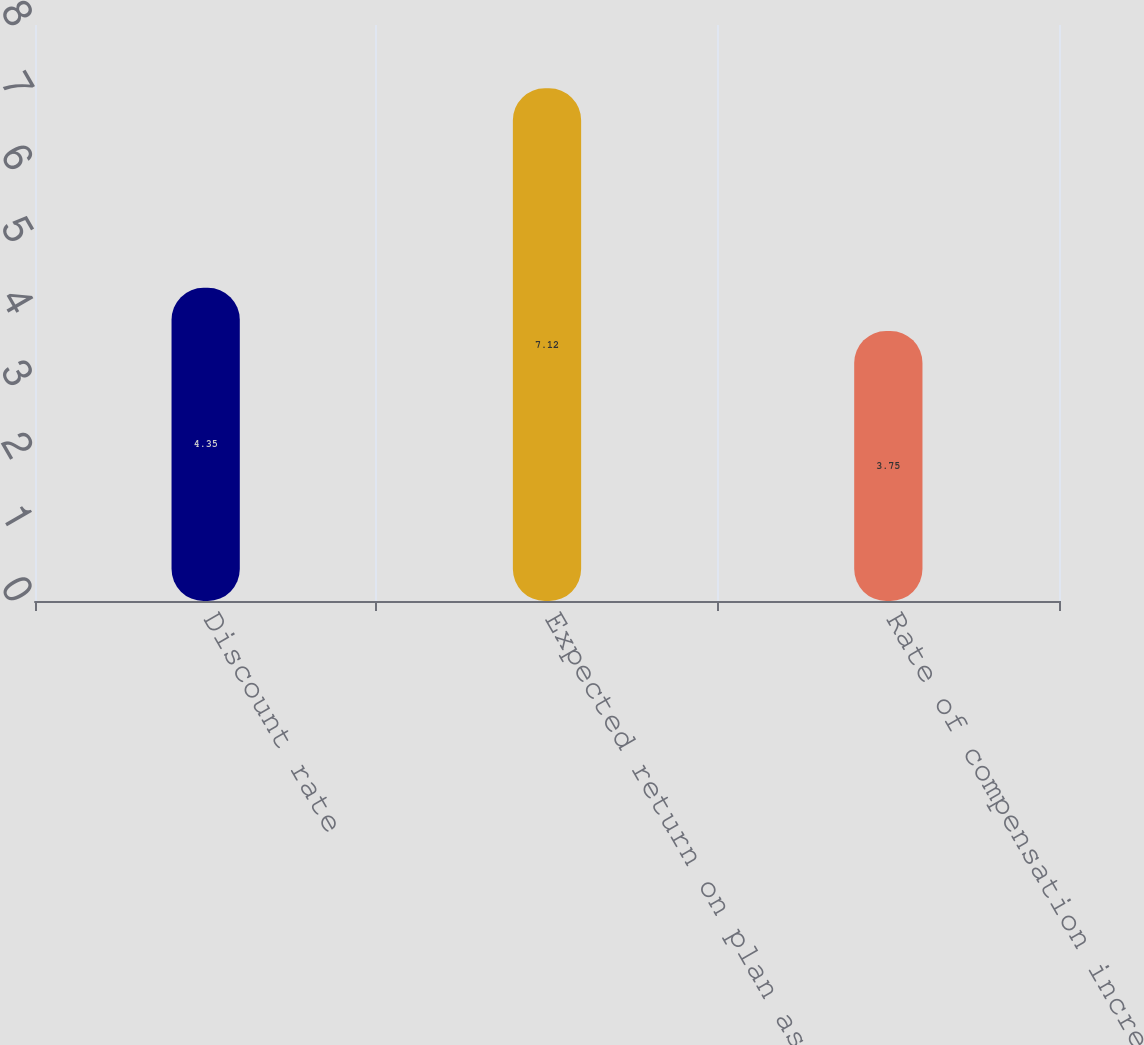Convert chart to OTSL. <chart><loc_0><loc_0><loc_500><loc_500><bar_chart><fcel>Discount rate<fcel>Expected return on plan assets<fcel>Rate of compensation increase<nl><fcel>4.35<fcel>7.12<fcel>3.75<nl></chart> 